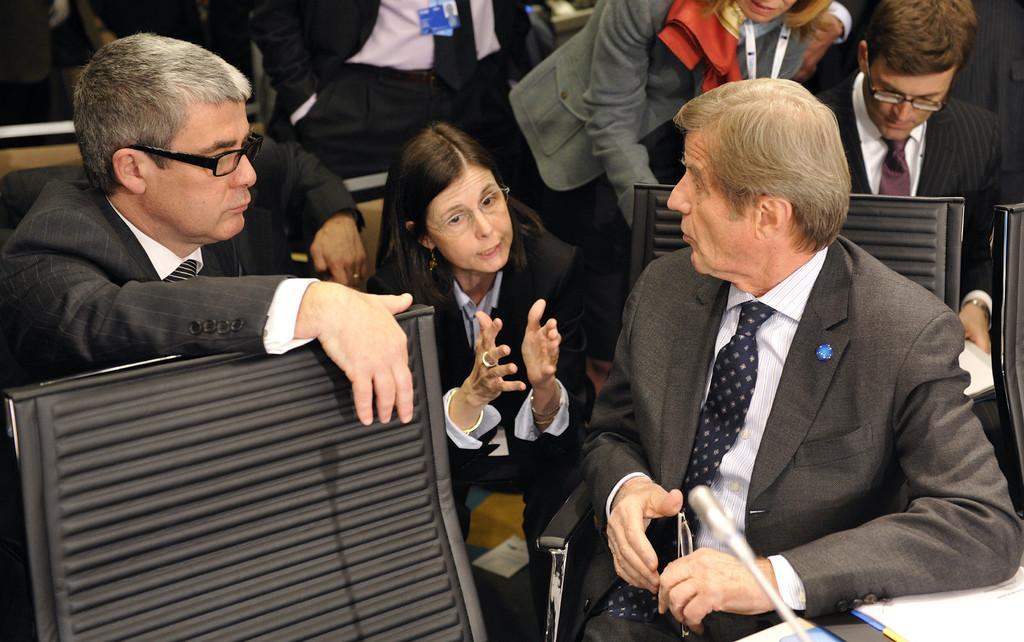Describe this image in one or two sentences. In this image, there are a few people. We can also see some chairs and a microphone. We can see some posters at the bottom. 